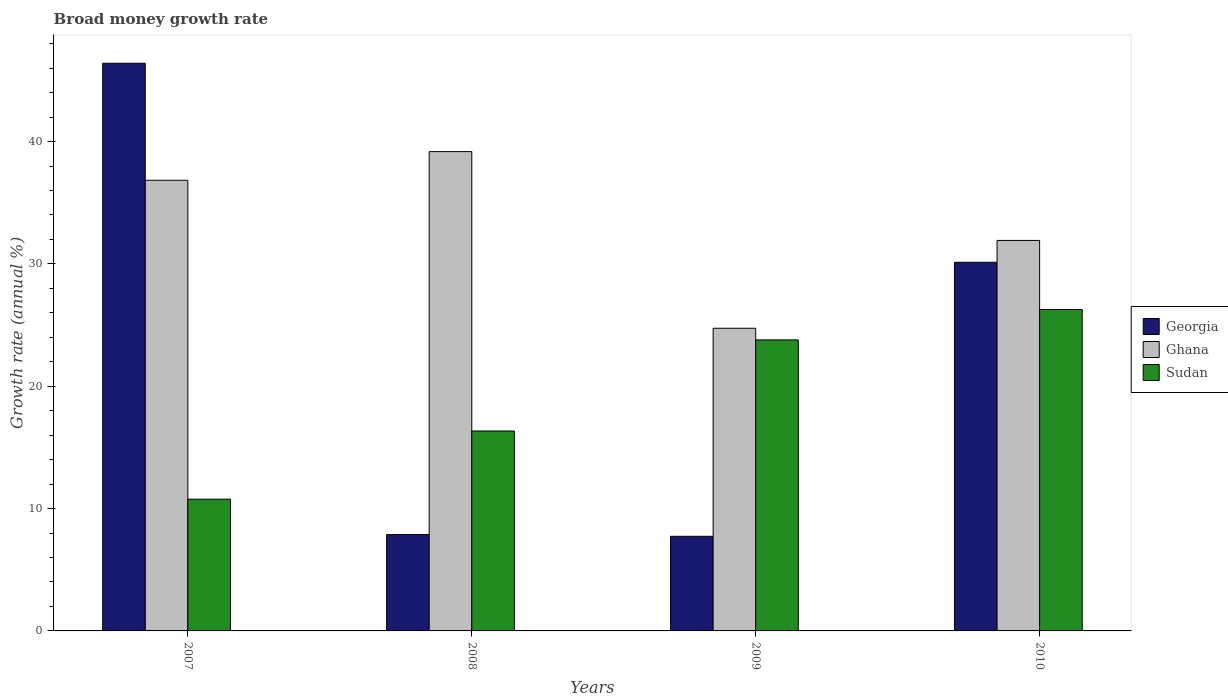Are the number of bars on each tick of the X-axis equal?
Offer a terse response. Yes. How many bars are there on the 4th tick from the left?
Provide a succinct answer. 3. How many bars are there on the 4th tick from the right?
Offer a terse response. 3. What is the label of the 2nd group of bars from the left?
Your answer should be very brief. 2008. What is the growth rate in Sudan in 2010?
Keep it short and to the point. 26.27. Across all years, what is the maximum growth rate in Ghana?
Ensure brevity in your answer.  39.18. Across all years, what is the minimum growth rate in Sudan?
Your response must be concise. 10.77. In which year was the growth rate in Georgia maximum?
Provide a short and direct response. 2007. In which year was the growth rate in Ghana minimum?
Your answer should be compact. 2009. What is the total growth rate in Sudan in the graph?
Your response must be concise. 77.17. What is the difference between the growth rate in Sudan in 2007 and that in 2008?
Offer a terse response. -5.57. What is the difference between the growth rate in Ghana in 2007 and the growth rate in Georgia in 2009?
Keep it short and to the point. 29.1. What is the average growth rate in Sudan per year?
Your answer should be very brief. 19.29. In the year 2007, what is the difference between the growth rate in Sudan and growth rate in Georgia?
Provide a short and direct response. -35.63. What is the ratio of the growth rate in Ghana in 2008 to that in 2010?
Keep it short and to the point. 1.23. What is the difference between the highest and the second highest growth rate in Georgia?
Provide a short and direct response. 16.27. What is the difference between the highest and the lowest growth rate in Georgia?
Provide a short and direct response. 38.67. Is the sum of the growth rate in Ghana in 2007 and 2008 greater than the maximum growth rate in Sudan across all years?
Provide a succinct answer. Yes. What does the 1st bar from the left in 2007 represents?
Your answer should be very brief. Georgia. What does the 1st bar from the right in 2010 represents?
Offer a very short reply. Sudan. How many bars are there?
Keep it short and to the point. 12. Are all the bars in the graph horizontal?
Ensure brevity in your answer.  No. How many years are there in the graph?
Ensure brevity in your answer.  4. Does the graph contain any zero values?
Provide a succinct answer. No. How many legend labels are there?
Offer a very short reply. 3. What is the title of the graph?
Your response must be concise. Broad money growth rate. Does "Albania" appear as one of the legend labels in the graph?
Offer a very short reply. No. What is the label or title of the Y-axis?
Provide a short and direct response. Growth rate (annual %). What is the Growth rate (annual %) of Georgia in 2007?
Your answer should be compact. 46.4. What is the Growth rate (annual %) in Ghana in 2007?
Keep it short and to the point. 36.83. What is the Growth rate (annual %) of Sudan in 2007?
Keep it short and to the point. 10.77. What is the Growth rate (annual %) in Georgia in 2008?
Your response must be concise. 7.88. What is the Growth rate (annual %) of Ghana in 2008?
Provide a short and direct response. 39.18. What is the Growth rate (annual %) in Sudan in 2008?
Your answer should be compact. 16.34. What is the Growth rate (annual %) of Georgia in 2009?
Offer a very short reply. 7.73. What is the Growth rate (annual %) in Ghana in 2009?
Offer a terse response. 24.74. What is the Growth rate (annual %) of Sudan in 2009?
Make the answer very short. 23.79. What is the Growth rate (annual %) in Georgia in 2010?
Make the answer very short. 30.13. What is the Growth rate (annual %) of Ghana in 2010?
Your answer should be compact. 31.92. What is the Growth rate (annual %) in Sudan in 2010?
Your answer should be compact. 26.27. Across all years, what is the maximum Growth rate (annual %) in Georgia?
Keep it short and to the point. 46.4. Across all years, what is the maximum Growth rate (annual %) in Ghana?
Your answer should be compact. 39.18. Across all years, what is the maximum Growth rate (annual %) in Sudan?
Offer a terse response. 26.27. Across all years, what is the minimum Growth rate (annual %) of Georgia?
Provide a succinct answer. 7.73. Across all years, what is the minimum Growth rate (annual %) of Ghana?
Give a very brief answer. 24.74. Across all years, what is the minimum Growth rate (annual %) of Sudan?
Offer a terse response. 10.77. What is the total Growth rate (annual %) in Georgia in the graph?
Offer a terse response. 92.14. What is the total Growth rate (annual %) in Ghana in the graph?
Make the answer very short. 132.67. What is the total Growth rate (annual %) of Sudan in the graph?
Your answer should be compact. 77.17. What is the difference between the Growth rate (annual %) in Georgia in 2007 and that in 2008?
Provide a succinct answer. 38.52. What is the difference between the Growth rate (annual %) in Ghana in 2007 and that in 2008?
Your answer should be compact. -2.34. What is the difference between the Growth rate (annual %) in Sudan in 2007 and that in 2008?
Provide a succinct answer. -5.57. What is the difference between the Growth rate (annual %) in Georgia in 2007 and that in 2009?
Ensure brevity in your answer.  38.67. What is the difference between the Growth rate (annual %) of Ghana in 2007 and that in 2009?
Your answer should be compact. 12.1. What is the difference between the Growth rate (annual %) of Sudan in 2007 and that in 2009?
Give a very brief answer. -13.02. What is the difference between the Growth rate (annual %) of Georgia in 2007 and that in 2010?
Ensure brevity in your answer.  16.27. What is the difference between the Growth rate (annual %) in Ghana in 2007 and that in 2010?
Your answer should be very brief. 4.92. What is the difference between the Growth rate (annual %) of Sudan in 2007 and that in 2010?
Your answer should be very brief. -15.5. What is the difference between the Growth rate (annual %) of Georgia in 2008 and that in 2009?
Keep it short and to the point. 0.14. What is the difference between the Growth rate (annual %) in Ghana in 2008 and that in 2009?
Provide a short and direct response. 14.44. What is the difference between the Growth rate (annual %) in Sudan in 2008 and that in 2009?
Give a very brief answer. -7.45. What is the difference between the Growth rate (annual %) of Georgia in 2008 and that in 2010?
Give a very brief answer. -22.26. What is the difference between the Growth rate (annual %) in Ghana in 2008 and that in 2010?
Provide a short and direct response. 7.26. What is the difference between the Growth rate (annual %) of Sudan in 2008 and that in 2010?
Your answer should be compact. -9.93. What is the difference between the Growth rate (annual %) in Georgia in 2009 and that in 2010?
Provide a short and direct response. -22.4. What is the difference between the Growth rate (annual %) of Ghana in 2009 and that in 2010?
Offer a very short reply. -7.18. What is the difference between the Growth rate (annual %) of Sudan in 2009 and that in 2010?
Give a very brief answer. -2.49. What is the difference between the Growth rate (annual %) of Georgia in 2007 and the Growth rate (annual %) of Ghana in 2008?
Your answer should be very brief. 7.22. What is the difference between the Growth rate (annual %) of Georgia in 2007 and the Growth rate (annual %) of Sudan in 2008?
Ensure brevity in your answer.  30.06. What is the difference between the Growth rate (annual %) in Ghana in 2007 and the Growth rate (annual %) in Sudan in 2008?
Ensure brevity in your answer.  20.49. What is the difference between the Growth rate (annual %) of Georgia in 2007 and the Growth rate (annual %) of Ghana in 2009?
Your answer should be compact. 21.66. What is the difference between the Growth rate (annual %) in Georgia in 2007 and the Growth rate (annual %) in Sudan in 2009?
Ensure brevity in your answer.  22.61. What is the difference between the Growth rate (annual %) in Ghana in 2007 and the Growth rate (annual %) in Sudan in 2009?
Ensure brevity in your answer.  13.05. What is the difference between the Growth rate (annual %) in Georgia in 2007 and the Growth rate (annual %) in Ghana in 2010?
Ensure brevity in your answer.  14.48. What is the difference between the Growth rate (annual %) of Georgia in 2007 and the Growth rate (annual %) of Sudan in 2010?
Keep it short and to the point. 20.13. What is the difference between the Growth rate (annual %) of Ghana in 2007 and the Growth rate (annual %) of Sudan in 2010?
Provide a succinct answer. 10.56. What is the difference between the Growth rate (annual %) in Georgia in 2008 and the Growth rate (annual %) in Ghana in 2009?
Ensure brevity in your answer.  -16.86. What is the difference between the Growth rate (annual %) of Georgia in 2008 and the Growth rate (annual %) of Sudan in 2009?
Make the answer very short. -15.91. What is the difference between the Growth rate (annual %) of Ghana in 2008 and the Growth rate (annual %) of Sudan in 2009?
Keep it short and to the point. 15.39. What is the difference between the Growth rate (annual %) in Georgia in 2008 and the Growth rate (annual %) in Ghana in 2010?
Provide a short and direct response. -24.04. What is the difference between the Growth rate (annual %) in Georgia in 2008 and the Growth rate (annual %) in Sudan in 2010?
Offer a terse response. -18.4. What is the difference between the Growth rate (annual %) in Ghana in 2008 and the Growth rate (annual %) in Sudan in 2010?
Your answer should be compact. 12.91. What is the difference between the Growth rate (annual %) of Georgia in 2009 and the Growth rate (annual %) of Ghana in 2010?
Your answer should be compact. -24.19. What is the difference between the Growth rate (annual %) in Georgia in 2009 and the Growth rate (annual %) in Sudan in 2010?
Your answer should be very brief. -18.54. What is the difference between the Growth rate (annual %) of Ghana in 2009 and the Growth rate (annual %) of Sudan in 2010?
Provide a short and direct response. -1.53. What is the average Growth rate (annual %) in Georgia per year?
Provide a succinct answer. 23.04. What is the average Growth rate (annual %) in Ghana per year?
Ensure brevity in your answer.  33.17. What is the average Growth rate (annual %) in Sudan per year?
Give a very brief answer. 19.29. In the year 2007, what is the difference between the Growth rate (annual %) of Georgia and Growth rate (annual %) of Ghana?
Offer a very short reply. 9.56. In the year 2007, what is the difference between the Growth rate (annual %) of Georgia and Growth rate (annual %) of Sudan?
Give a very brief answer. 35.63. In the year 2007, what is the difference between the Growth rate (annual %) of Ghana and Growth rate (annual %) of Sudan?
Your response must be concise. 26.07. In the year 2008, what is the difference between the Growth rate (annual %) of Georgia and Growth rate (annual %) of Ghana?
Provide a short and direct response. -31.3. In the year 2008, what is the difference between the Growth rate (annual %) in Georgia and Growth rate (annual %) in Sudan?
Keep it short and to the point. -8.47. In the year 2008, what is the difference between the Growth rate (annual %) of Ghana and Growth rate (annual %) of Sudan?
Keep it short and to the point. 22.84. In the year 2009, what is the difference between the Growth rate (annual %) of Georgia and Growth rate (annual %) of Ghana?
Your answer should be compact. -17.01. In the year 2009, what is the difference between the Growth rate (annual %) of Georgia and Growth rate (annual %) of Sudan?
Your response must be concise. -16.05. In the year 2009, what is the difference between the Growth rate (annual %) in Ghana and Growth rate (annual %) in Sudan?
Your response must be concise. 0.95. In the year 2010, what is the difference between the Growth rate (annual %) of Georgia and Growth rate (annual %) of Ghana?
Your answer should be compact. -1.79. In the year 2010, what is the difference between the Growth rate (annual %) of Georgia and Growth rate (annual %) of Sudan?
Your response must be concise. 3.86. In the year 2010, what is the difference between the Growth rate (annual %) of Ghana and Growth rate (annual %) of Sudan?
Give a very brief answer. 5.65. What is the ratio of the Growth rate (annual %) of Georgia in 2007 to that in 2008?
Your response must be concise. 5.89. What is the ratio of the Growth rate (annual %) in Ghana in 2007 to that in 2008?
Offer a terse response. 0.94. What is the ratio of the Growth rate (annual %) in Sudan in 2007 to that in 2008?
Your answer should be compact. 0.66. What is the ratio of the Growth rate (annual %) in Georgia in 2007 to that in 2009?
Make the answer very short. 6. What is the ratio of the Growth rate (annual %) of Ghana in 2007 to that in 2009?
Offer a very short reply. 1.49. What is the ratio of the Growth rate (annual %) of Sudan in 2007 to that in 2009?
Make the answer very short. 0.45. What is the ratio of the Growth rate (annual %) of Georgia in 2007 to that in 2010?
Your answer should be compact. 1.54. What is the ratio of the Growth rate (annual %) of Ghana in 2007 to that in 2010?
Make the answer very short. 1.15. What is the ratio of the Growth rate (annual %) of Sudan in 2007 to that in 2010?
Make the answer very short. 0.41. What is the ratio of the Growth rate (annual %) of Georgia in 2008 to that in 2009?
Offer a very short reply. 1.02. What is the ratio of the Growth rate (annual %) of Ghana in 2008 to that in 2009?
Offer a terse response. 1.58. What is the ratio of the Growth rate (annual %) in Sudan in 2008 to that in 2009?
Your answer should be compact. 0.69. What is the ratio of the Growth rate (annual %) in Georgia in 2008 to that in 2010?
Your answer should be very brief. 0.26. What is the ratio of the Growth rate (annual %) of Ghana in 2008 to that in 2010?
Offer a very short reply. 1.23. What is the ratio of the Growth rate (annual %) of Sudan in 2008 to that in 2010?
Make the answer very short. 0.62. What is the ratio of the Growth rate (annual %) of Georgia in 2009 to that in 2010?
Your answer should be very brief. 0.26. What is the ratio of the Growth rate (annual %) of Ghana in 2009 to that in 2010?
Ensure brevity in your answer.  0.78. What is the ratio of the Growth rate (annual %) in Sudan in 2009 to that in 2010?
Your response must be concise. 0.91. What is the difference between the highest and the second highest Growth rate (annual %) in Georgia?
Keep it short and to the point. 16.27. What is the difference between the highest and the second highest Growth rate (annual %) in Ghana?
Provide a succinct answer. 2.34. What is the difference between the highest and the second highest Growth rate (annual %) in Sudan?
Offer a terse response. 2.49. What is the difference between the highest and the lowest Growth rate (annual %) of Georgia?
Give a very brief answer. 38.67. What is the difference between the highest and the lowest Growth rate (annual %) of Ghana?
Offer a terse response. 14.44. What is the difference between the highest and the lowest Growth rate (annual %) in Sudan?
Your answer should be very brief. 15.5. 